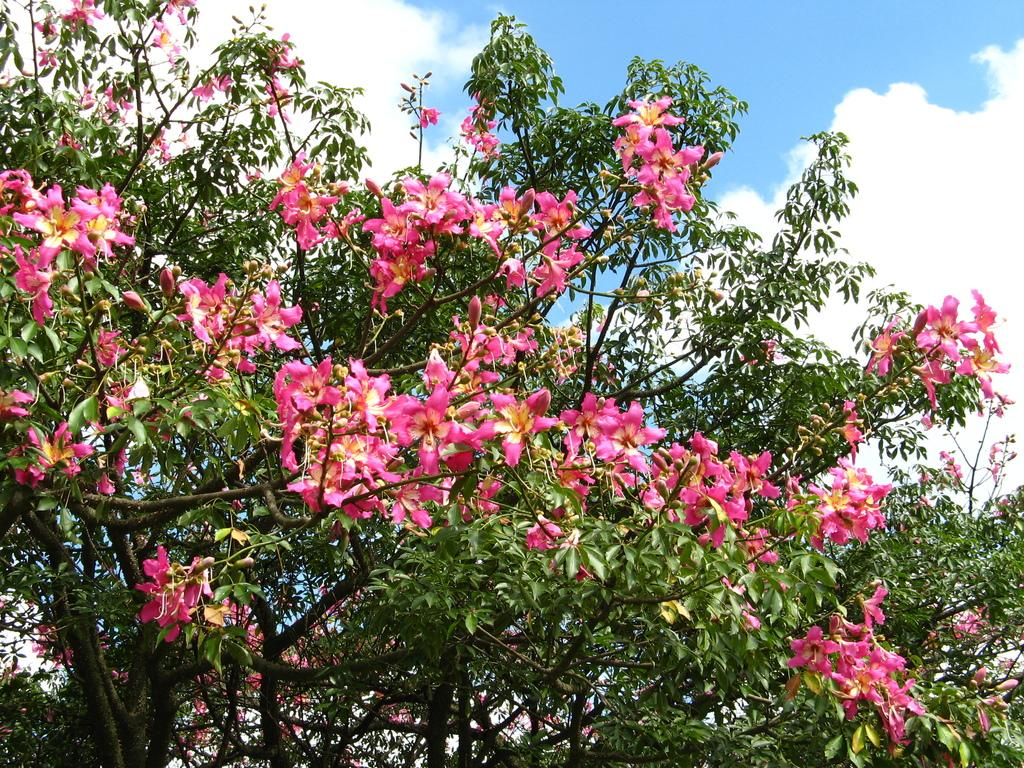What type of vegetation is visible in the image? There are many branches of a tree in the image. What can be seen on the tree branches? There are many flowers on the tree branches. What is visible in the background of the image? The background of the image is the sky. What type of toothpaste is being used to clean the branches in the image? There is no toothpaste or cleaning activity present in the image; it features a tree with flowers on its branches against a sky background. 